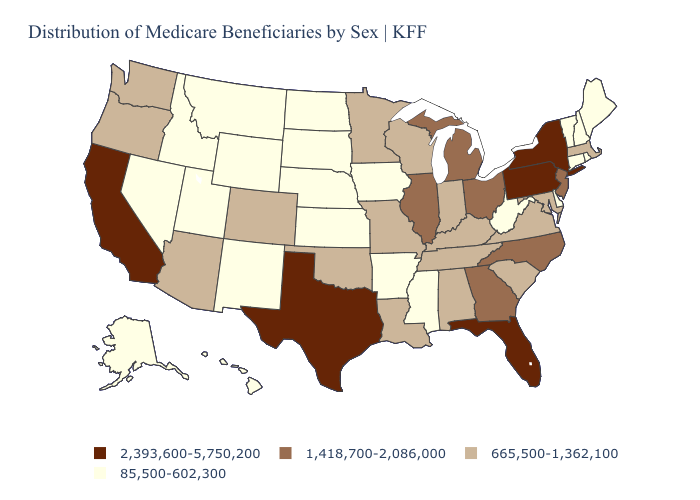Does Connecticut have the lowest value in the Northeast?
Concise answer only. Yes. What is the value of California?
Keep it brief. 2,393,600-5,750,200. What is the highest value in the USA?
Quick response, please. 2,393,600-5,750,200. Does Texas have the same value as California?
Write a very short answer. Yes. Name the states that have a value in the range 2,393,600-5,750,200?
Answer briefly. California, Florida, New York, Pennsylvania, Texas. What is the value of Kansas?
Write a very short answer. 85,500-602,300. What is the value of Alaska?
Be succinct. 85,500-602,300. Name the states that have a value in the range 1,418,700-2,086,000?
Give a very brief answer. Georgia, Illinois, Michigan, New Jersey, North Carolina, Ohio. Among the states that border Oregon , does Washington have the lowest value?
Answer briefly. No. Does Montana have a higher value than Michigan?
Answer briefly. No. Does Arkansas have a lower value than Florida?
Quick response, please. Yes. Which states have the lowest value in the South?
Keep it brief. Arkansas, Delaware, Mississippi, West Virginia. What is the lowest value in states that border New Jersey?
Short answer required. 85,500-602,300. Which states have the lowest value in the USA?
Keep it brief. Alaska, Arkansas, Connecticut, Delaware, Hawaii, Idaho, Iowa, Kansas, Maine, Mississippi, Montana, Nebraska, Nevada, New Hampshire, New Mexico, North Dakota, Rhode Island, South Dakota, Utah, Vermont, West Virginia, Wyoming. Name the states that have a value in the range 665,500-1,362,100?
Write a very short answer. Alabama, Arizona, Colorado, Indiana, Kentucky, Louisiana, Maryland, Massachusetts, Minnesota, Missouri, Oklahoma, Oregon, South Carolina, Tennessee, Virginia, Washington, Wisconsin. 